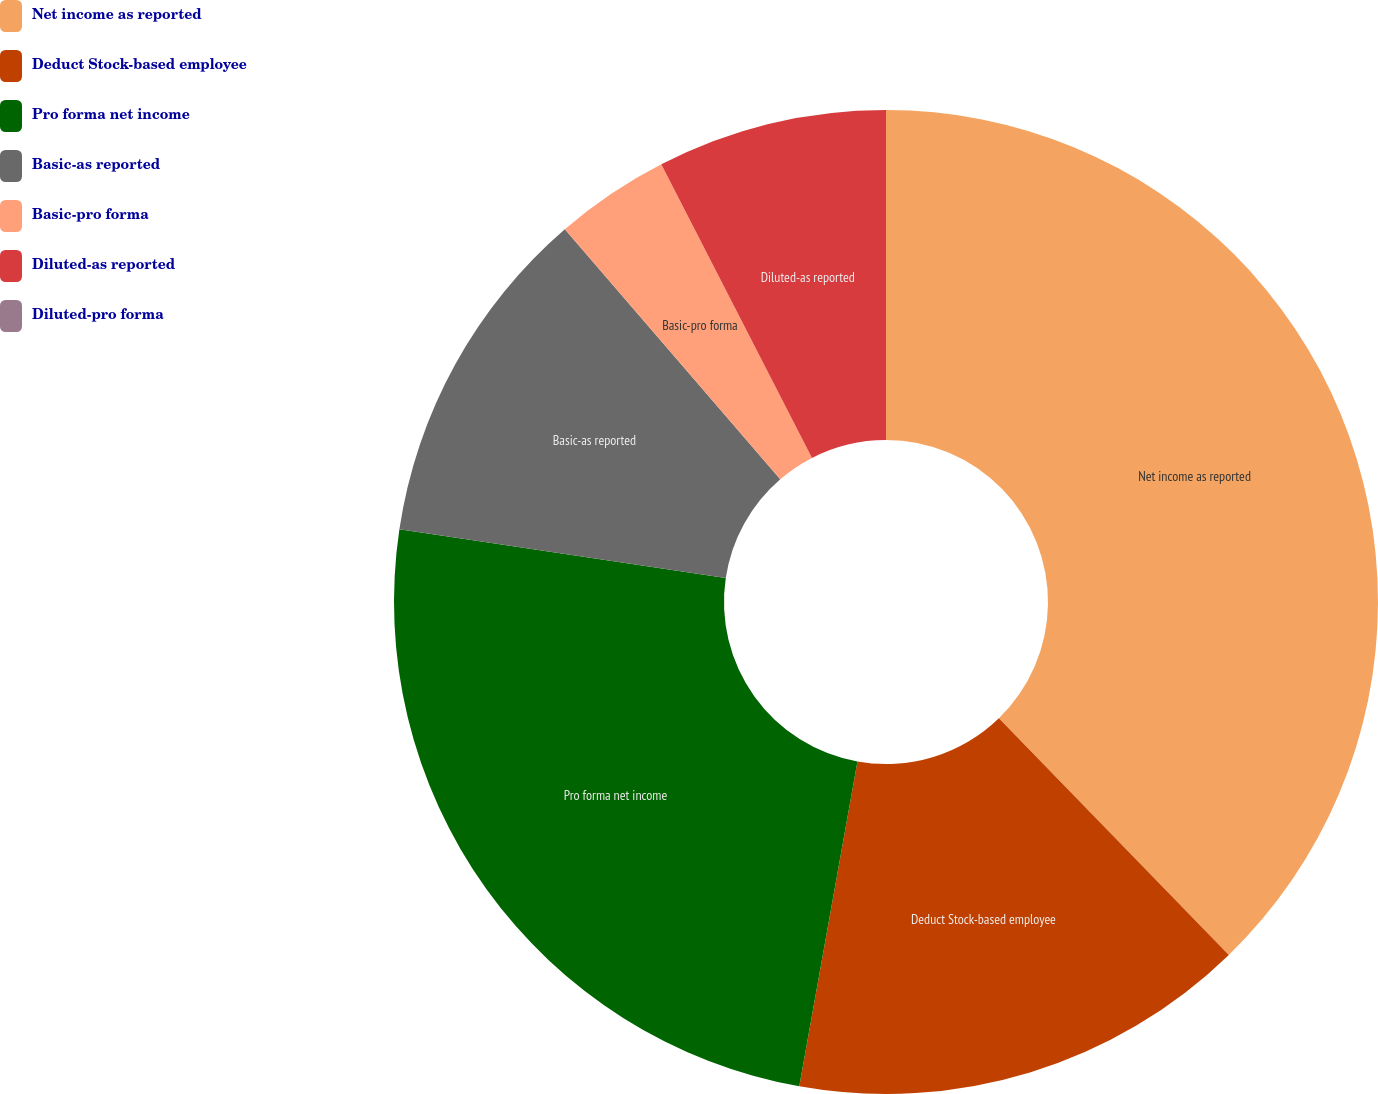Convert chart to OTSL. <chart><loc_0><loc_0><loc_500><loc_500><pie_chart><fcel>Net income as reported<fcel>Deduct Stock-based employee<fcel>Pro forma net income<fcel>Basic-as reported<fcel>Basic-pro forma<fcel>Diluted-as reported<fcel>Diluted-pro forma<nl><fcel>37.73%<fcel>15.09%<fcel>24.54%<fcel>11.32%<fcel>3.77%<fcel>7.55%<fcel>0.0%<nl></chart> 